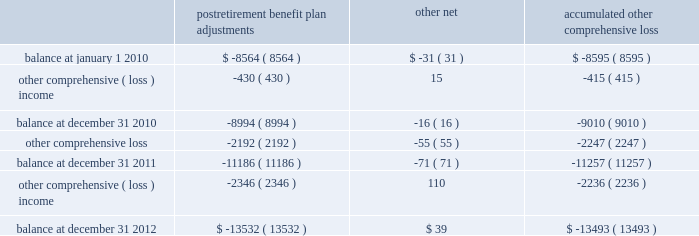Until the hedged transaction is recognized in earnings .
Changes in the fair value of the derivatives that are attributable to the ineffective portion of the hedges , or of derivatives that are not considered to be highly effective hedges , if any , are immediately recognized in earnings .
The aggregate notional amount of our outstanding foreign currency hedges at december 31 , 2012 and 2011 was $ 1.3 billion and $ 1.7 billion .
The aggregate notional amount of our outstanding interest rate swaps at december 31 , 2012 and 2011 was $ 503 million and $ 450 million .
Derivative instruments did not have a material impact on net earnings and comprehensive income during 2012 , 2011 , and 2010 .
Substantially all of our derivatives are designated for hedge accounting .
See note 15 for more information on the fair value measurements related to our derivative instruments .
Stock-based compensation 2013 compensation cost related to all share-based payments including stock options and restricted stock units is measured at the grant date based on the estimated fair value of the award .
We generally recognize the compensation cost ratably over a three-year vesting period .
Income taxes 2013 we periodically assess our tax filing exposures related to periods that are open to examination .
Based on the latest available information , we evaluate our tax positions to determine whether the position will more likely than not be sustained upon examination by the internal revenue service ( irs ) .
If we cannot reach a more-likely-than-not determination , no benefit is recorded .
If we determine that the tax position is more likely than not to be sustained , we record the largest amount of benefit that is more likely than not to be realized when the tax position is settled .
We record interest and penalties related to income taxes as a component of income tax expense on our statements of earnings .
Interest and penalties are not material .
Accumulated other comprehensive loss 2013 changes in the balance of accumulated other comprehensive loss , net of income taxes , consisted of the following ( in millions ) : postretirement benefit plan adjustments other , net accumulated comprehensive .
The postretirement benefit plan adjustments are shown net of tax benefits at december 31 , 2012 , 2011 , and 2010 of $ 7.4 billion , $ 6.1 billion , and $ 4.9 billion .
These tax benefits include amounts recognized on our income tax returns as current deductions and deferred income taxes , which will be recognized on our tax returns in future years .
See note 7 and note 9 for more information on our income taxes and postretirement plans .
Recent accounting pronouncements 2013 effective january 1 , 2012 , we retrospectively adopted new guidance issued by the financial accounting standards board by presenting total comprehensive income and the components of net income and other comprehensive loss in two separate but consecutive statements .
The adoption of this guidance resulted only in a change in how we present other comprehensive loss in our consolidated financial statements and did not have any impact on our results of operations , financial position , or cash flows. .
What is the percentage change in aggregate notional amount of outstanding interest rate swaps from 2011 to 2012? 
Computations: ((503 - 450) / 450)
Answer: 0.11778. Until the hedged transaction is recognized in earnings .
Changes in the fair value of the derivatives that are attributable to the ineffective portion of the hedges , or of derivatives that are not considered to be highly effective hedges , if any , are immediately recognized in earnings .
The aggregate notional amount of our outstanding foreign currency hedges at december 31 , 2012 and 2011 was $ 1.3 billion and $ 1.7 billion .
The aggregate notional amount of our outstanding interest rate swaps at december 31 , 2012 and 2011 was $ 503 million and $ 450 million .
Derivative instruments did not have a material impact on net earnings and comprehensive income during 2012 , 2011 , and 2010 .
Substantially all of our derivatives are designated for hedge accounting .
See note 15 for more information on the fair value measurements related to our derivative instruments .
Stock-based compensation 2013 compensation cost related to all share-based payments including stock options and restricted stock units is measured at the grant date based on the estimated fair value of the award .
We generally recognize the compensation cost ratably over a three-year vesting period .
Income taxes 2013 we periodically assess our tax filing exposures related to periods that are open to examination .
Based on the latest available information , we evaluate our tax positions to determine whether the position will more likely than not be sustained upon examination by the internal revenue service ( irs ) .
If we cannot reach a more-likely-than-not determination , no benefit is recorded .
If we determine that the tax position is more likely than not to be sustained , we record the largest amount of benefit that is more likely than not to be realized when the tax position is settled .
We record interest and penalties related to income taxes as a component of income tax expense on our statements of earnings .
Interest and penalties are not material .
Accumulated other comprehensive loss 2013 changes in the balance of accumulated other comprehensive loss , net of income taxes , consisted of the following ( in millions ) : postretirement benefit plan adjustments other , net accumulated comprehensive .
The postretirement benefit plan adjustments are shown net of tax benefits at december 31 , 2012 , 2011 , and 2010 of $ 7.4 billion , $ 6.1 billion , and $ 4.9 billion .
These tax benefits include amounts recognized on our income tax returns as current deductions and deferred income taxes , which will be recognized on our tax returns in future years .
See note 7 and note 9 for more information on our income taxes and postretirement plans .
Recent accounting pronouncements 2013 effective january 1 , 2012 , we retrospectively adopted new guidance issued by the financial accounting standards board by presenting total comprehensive income and the components of net income and other comprehensive loss in two separate but consecutive statements .
The adoption of this guidance resulted only in a change in how we present other comprehensive loss in our consolidated financial statements and did not have any impact on our results of operations , financial position , or cash flows. .
In 2010 what was the percent of the change in the post retirement benefit plan adjustments? 
Computations: ((8994 - 8564) / 8564)
Answer: 0.05021. 